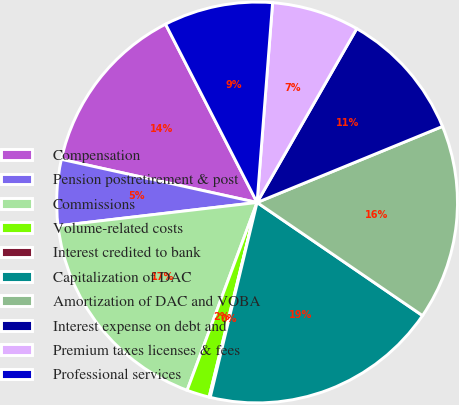Convert chart. <chart><loc_0><loc_0><loc_500><loc_500><pie_chart><fcel>Compensation<fcel>Pension postretirement & post<fcel>Commissions<fcel>Volume-related costs<fcel>Interest credited to bank<fcel>Capitalization of DAC<fcel>Amortization of DAC and VOBA<fcel>Interest expense on debt and<fcel>Premium taxes licenses & fees<fcel>Professional services<nl><fcel>14.0%<fcel>5.31%<fcel>17.47%<fcel>1.83%<fcel>0.09%<fcel>19.21%<fcel>15.74%<fcel>10.52%<fcel>7.05%<fcel>8.78%<nl></chart> 